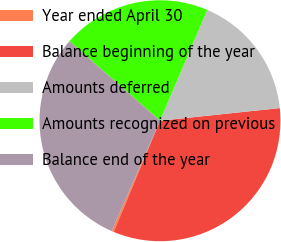Convert chart to OTSL. <chart><loc_0><loc_0><loc_500><loc_500><pie_chart><fcel>Year ended April 30<fcel>Balance beginning of the year<fcel>Amounts deferred<fcel>Amounts recognized on previous<fcel>Balance end of the year<nl><fcel>0.28%<fcel>32.95%<fcel>16.91%<fcel>19.95%<fcel>29.91%<nl></chart> 